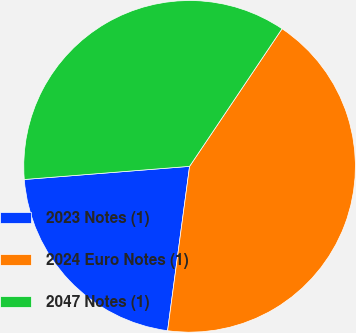Convert chart. <chart><loc_0><loc_0><loc_500><loc_500><pie_chart><fcel>2023 Notes (1)<fcel>2024 Euro Notes (1)<fcel>2047 Notes (1)<nl><fcel>21.62%<fcel>42.7%<fcel>35.68%<nl></chart> 